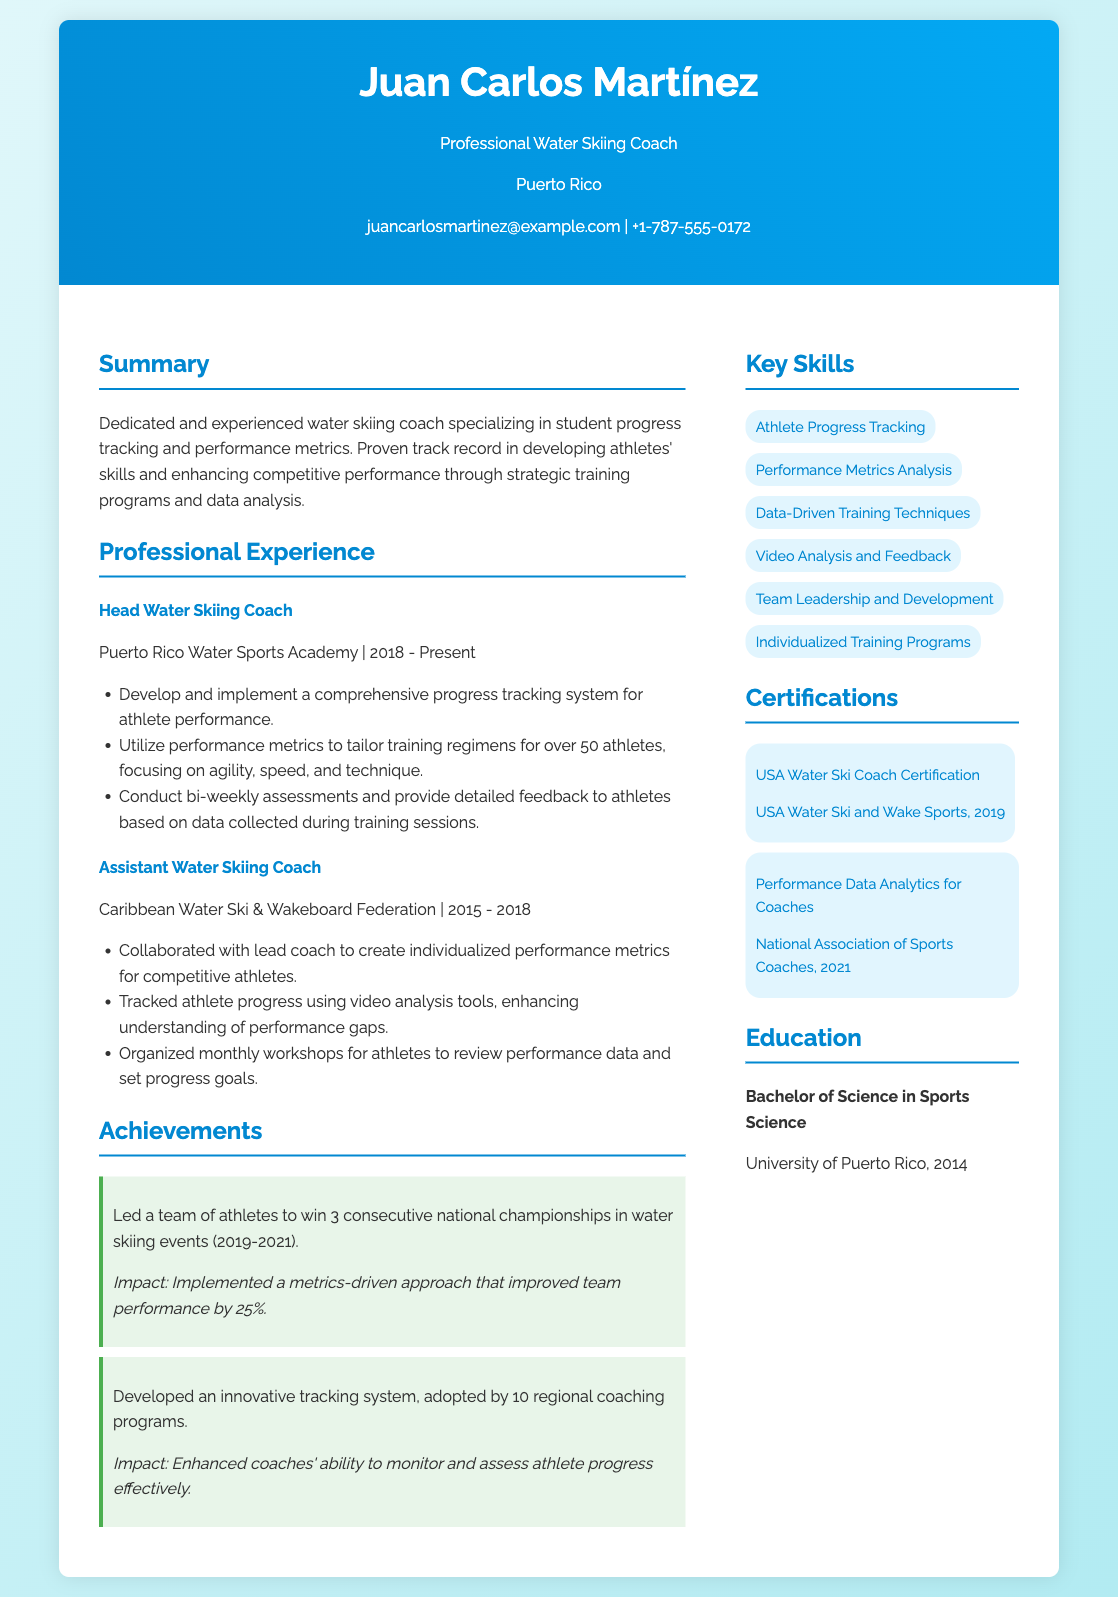What is Juan Carlos Martínez's profession? His profession is stated in the header of the resume.
Answer: Water Skiing Coach Which organization did Juan Carlos Martínez work for from 2018 to present? This information is found under his professional experience.
Answer: Puerto Rico Water Sports Academy How many athletes does he tailor training regimens for? The number of athletes is specified in the duties of his current job.
Answer: Over 50 What is the highest degree Juan Carlos Martínez holds? This information is listed under the education section.
Answer: Bachelor of Science in Sports Science In which year did he receive the USA Water Ski Coach Certification? The date of certification is mentioned in the certifications section.
Answer: 2019 What was the impact of the metrics-driven approach he implemented? The impact of the approach is detailed in the achievements section.
Answer: Improved team performance by 25% How many consecutive national championships did his team win? This detail is found in his achievements.
Answer: 3 What type of tools did he use for progress tracking while working as an Assistant Coach? The type of tools is mentioned in the job responsibilities.
Answer: Video analysis tools How many regional coaching programs adopted his innovative tracking system? This statistic is included in his achievements.
Answer: 10 